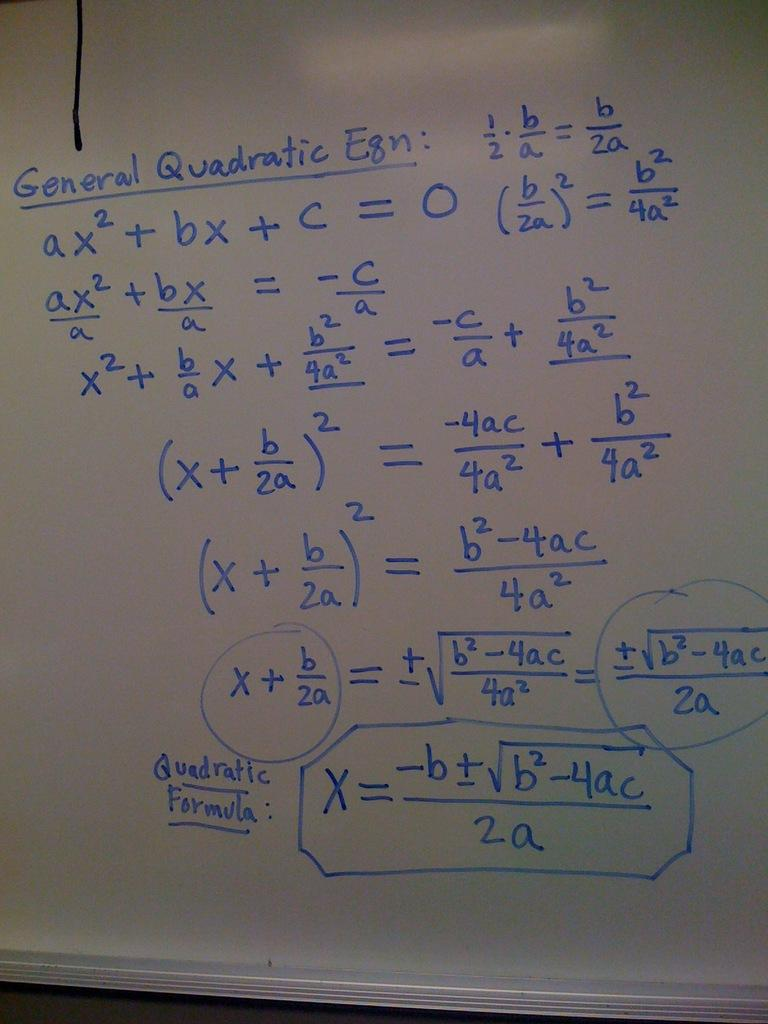<image>
Offer a succinct explanation of the picture presented. A chalkboard with complicated math problems on it. 